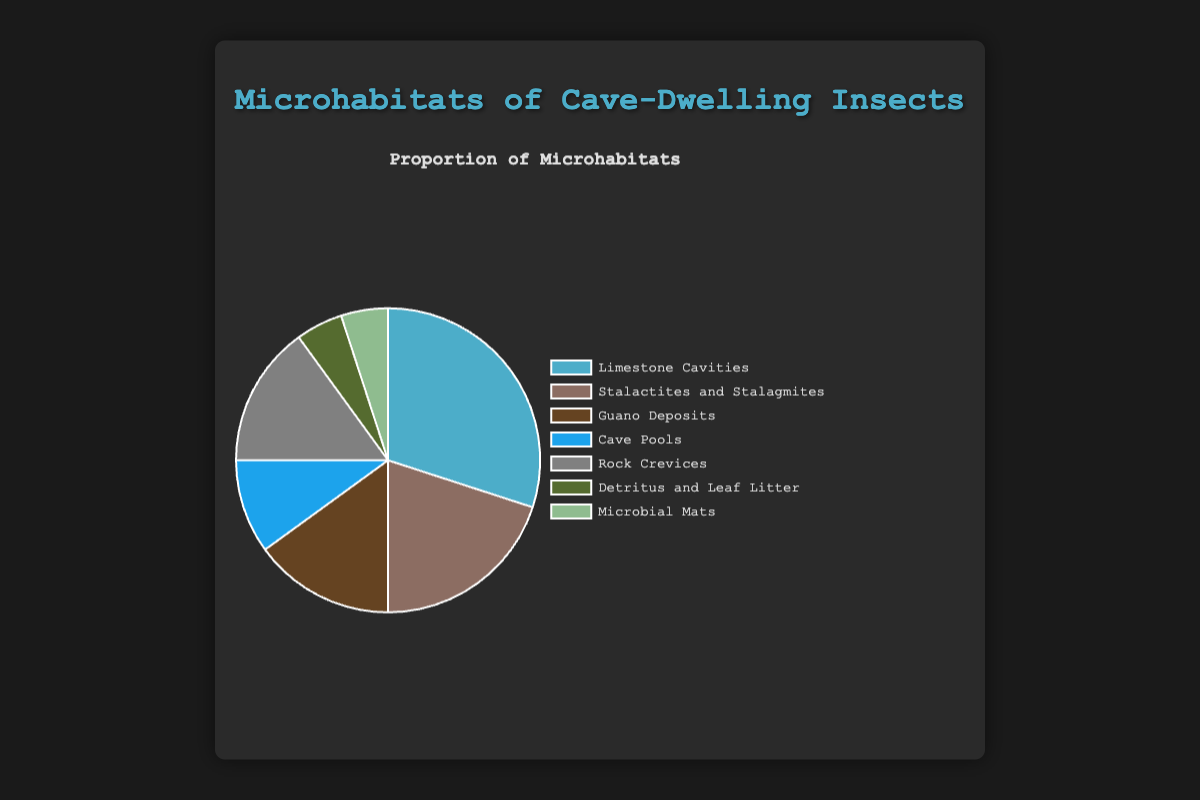What is the most common microhabitat utilized by cave-dwelling insects? By examining the pie chart, we can see that the largest segment represents "Limestone Cavities" with a proportion of 30%. Hence, "Limestone Cavities" is the most common microhabitat.
Answer: Limestone Cavities Which microhabitat has the smallest utilization and what is its proportion? The smallest segments in the pie chart denote "Detritus and Leaf Litter" and "Microbial Mats," each with proportions of 5%. This indicates that these two are the least utilized microhabitats.
Answer: Detritus and Leaf Litter and Microbial Mats with 5% How much more is the proportion of insects that utilize Limestone Cavities compared to those that utilize Guano Deposits? The proportion for "Limestone Cavities" is 30%, and for "Guano Deposits" it is 15%. Subtracting these values gives us the difference: 30% - 15% = 15%.
Answer: 15% Which two microhabitats have the same proportion of utilization by cave-dwelling insects? By looking at the pie chart, it's evident that "Guano Deposits" and "Rock Crevices" both have a proportion of 15%.
Answer: Guano Deposits and Rock Crevices What is the combined proportion of cave-dwelling insects that utilize Cave Pools and Stalactites and Stalagmites? The chart shows that "Cave Pools" have 10% and "Stalactites and Stalagmites" have 20%. Adding these proportions gives 10% + 20% = 30%.
Answer: 30% Which microhabitat occupies the largest visual slice in the chart? The visual representation of the pie chart shows that the largest slice corresponds to "Limestone Cavities" with a proportion of 30%.
Answer: Limestone Cavities What proportion of the microhabitats are utilized by cave-dwelling insects in total? A pie chart represents 100% of the data, meaning 100% of the microhabitats are utilized by cave-dwelling insects.
Answer: 100% Compare the utilization of Rock Crevices and Cave Pools. Which one is more, and by how much? "Rock Crevices" have a proportion of 15%, while "Cave Pools" have 10%. Subtracting these values gives us the difference: 15% - 10% = 5%. Therefore, Rock Crevices are utilized 5% more than Cave Pools.
Answer: Rock Crevices by 5% Which microhabitat is represented by a green slice in the pie chart? Observing the pie chart, the green slice represents "Detritus and Leaf Litter," which has a proportion of 5%.
Answer: Detritus and Leaf Litter 